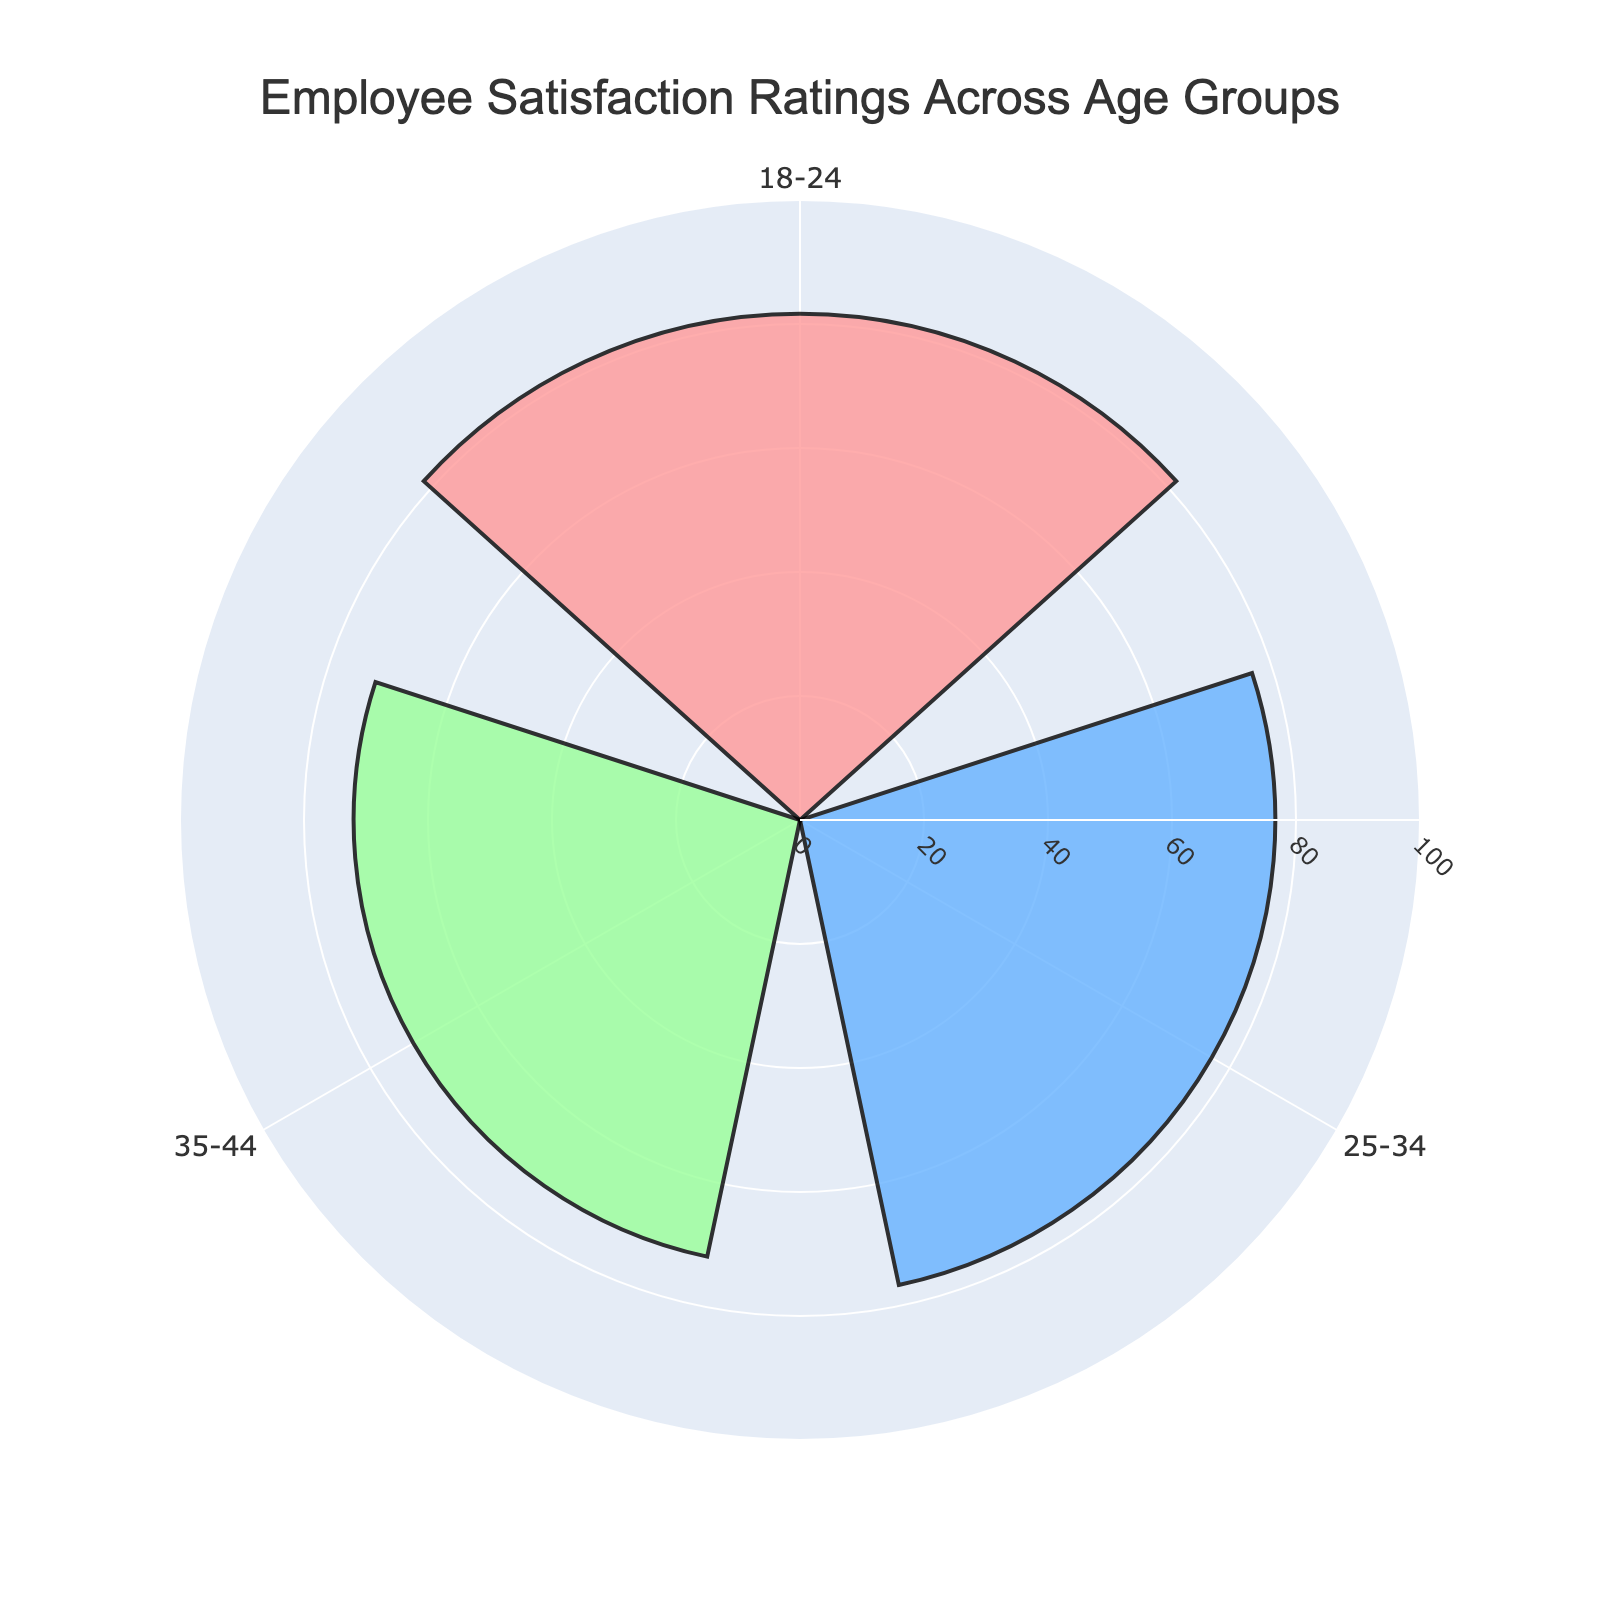How many age groups are represented in the chart? Count the distinct age groups visible in the figure. There are three age groups: 18-24, 25-34, and 35-44.
Answer: 3 What is the title of the chart? Look at the top of the chart; the title is usually prominently displayed there. The title of this chart is "Employee Satisfaction Ratings Across Age Groups".
Answer: Employee Satisfaction Ratings Across Age Groups Which age group has the highest mean employee satisfaction rating? Compare the lengths of the bars corresponding to each age group. The 18-24 age group has the highest mean satisfaction rating, as indicated by the longest bar.
Answer: 18-24 What's the average employee satisfaction rating for the 25-34 age group? The average rating is calculated as the mean of ratings in the 25-34 age group. The ratings are 74, 77, and 79. Average = (74 + 77 + 79) / 3 = 76.7
Answer: 76.7 How does the satisfaction rating of the 35-44 age group compare to that of the 18-24 age group? Compare the values of the mean ratings for 18-24 and 35-44 age groups. The mean rating for 35-44 is 72, and for 18-24, it is 81.7. Therefore, the rating for the 35-44 age group is lower.
Answer: Lower What's the difference in employee satisfaction ratings between the highest and lowest age groups? Identify the highest and lowest mean ratings from the chart and subtract. The highest rating is for 18-24 (81.7) and the lowest is for 35-44 (72). Difference = 81.7 - 72 = 9.7
Answer: 9.7 What color represents the 25-34 age group on the chart? Identify the color associated with the bar for the 25-34 age group. The 25-34 age group is represented by a blue color.
Answer: Blue Which age group has the smallest range in their employee satisfaction ratings based on the mean values displayed? Compare the spread (length) of bars for each age group. The age groups don't have ranges explicitly shown, but the bar lengths indicate central tendency. All bars are directly related to mean values; hence this question doesn't apply as intended since we're using means.
Answer: N/A What angular offset is used to display the annotations in the chart? Observe how annotations are placed relative to each age group's bar. The annotations offset seems to be 60 degrees more than the natural 120 degrees interval between groups.
Answer: 60 degrees 